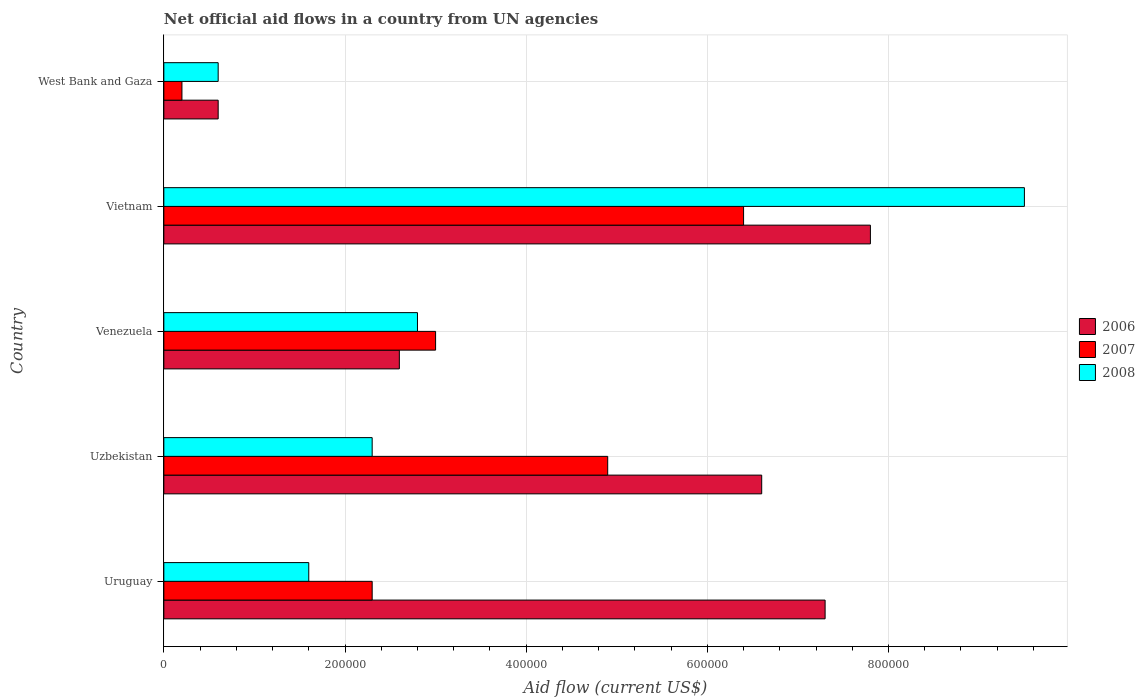Are the number of bars on each tick of the Y-axis equal?
Provide a short and direct response. Yes. How many bars are there on the 4th tick from the top?
Provide a succinct answer. 3. How many bars are there on the 2nd tick from the bottom?
Keep it short and to the point. 3. What is the label of the 4th group of bars from the top?
Make the answer very short. Uzbekistan. In how many cases, is the number of bars for a given country not equal to the number of legend labels?
Your response must be concise. 0. What is the net official aid flow in 2008 in West Bank and Gaza?
Make the answer very short. 6.00e+04. Across all countries, what is the maximum net official aid flow in 2008?
Keep it short and to the point. 9.50e+05. In which country was the net official aid flow in 2006 maximum?
Keep it short and to the point. Vietnam. In which country was the net official aid flow in 2006 minimum?
Offer a terse response. West Bank and Gaza. What is the total net official aid flow in 2006 in the graph?
Ensure brevity in your answer.  2.49e+06. What is the difference between the net official aid flow in 2008 in Vietnam and that in West Bank and Gaza?
Provide a short and direct response. 8.90e+05. What is the average net official aid flow in 2006 per country?
Your response must be concise. 4.98e+05. In how many countries, is the net official aid flow in 2006 greater than 560000 US$?
Provide a short and direct response. 3. Is the net official aid flow in 2006 in Uruguay less than that in Venezuela?
Offer a terse response. No. What is the difference between the highest and the lowest net official aid flow in 2006?
Ensure brevity in your answer.  7.20e+05. In how many countries, is the net official aid flow in 2007 greater than the average net official aid flow in 2007 taken over all countries?
Provide a short and direct response. 2. Is the sum of the net official aid flow in 2008 in Venezuela and Vietnam greater than the maximum net official aid flow in 2007 across all countries?
Ensure brevity in your answer.  Yes. Are all the bars in the graph horizontal?
Keep it short and to the point. Yes. What is the difference between two consecutive major ticks on the X-axis?
Offer a terse response. 2.00e+05. Does the graph contain any zero values?
Your answer should be very brief. No. Does the graph contain grids?
Your response must be concise. Yes. Where does the legend appear in the graph?
Keep it short and to the point. Center right. How many legend labels are there?
Keep it short and to the point. 3. How are the legend labels stacked?
Give a very brief answer. Vertical. What is the title of the graph?
Offer a terse response. Net official aid flows in a country from UN agencies. What is the label or title of the X-axis?
Offer a terse response. Aid flow (current US$). What is the Aid flow (current US$) in 2006 in Uruguay?
Your answer should be very brief. 7.30e+05. What is the Aid flow (current US$) of 2008 in Uruguay?
Provide a short and direct response. 1.60e+05. What is the Aid flow (current US$) of 2006 in Uzbekistan?
Give a very brief answer. 6.60e+05. What is the Aid flow (current US$) of 2007 in Venezuela?
Offer a very short reply. 3.00e+05. What is the Aid flow (current US$) in 2006 in Vietnam?
Ensure brevity in your answer.  7.80e+05. What is the Aid flow (current US$) in 2007 in Vietnam?
Your answer should be compact. 6.40e+05. What is the Aid flow (current US$) in 2008 in Vietnam?
Offer a very short reply. 9.50e+05. What is the Aid flow (current US$) in 2006 in West Bank and Gaza?
Keep it short and to the point. 6.00e+04. What is the Aid flow (current US$) of 2007 in West Bank and Gaza?
Your response must be concise. 2.00e+04. Across all countries, what is the maximum Aid flow (current US$) in 2006?
Give a very brief answer. 7.80e+05. Across all countries, what is the maximum Aid flow (current US$) of 2007?
Your answer should be very brief. 6.40e+05. Across all countries, what is the maximum Aid flow (current US$) in 2008?
Your answer should be compact. 9.50e+05. Across all countries, what is the minimum Aid flow (current US$) of 2008?
Ensure brevity in your answer.  6.00e+04. What is the total Aid flow (current US$) of 2006 in the graph?
Your answer should be very brief. 2.49e+06. What is the total Aid flow (current US$) in 2007 in the graph?
Give a very brief answer. 1.68e+06. What is the total Aid flow (current US$) in 2008 in the graph?
Offer a terse response. 1.68e+06. What is the difference between the Aid flow (current US$) in 2007 in Uruguay and that in Uzbekistan?
Offer a very short reply. -2.60e+05. What is the difference between the Aid flow (current US$) in 2006 in Uruguay and that in Venezuela?
Keep it short and to the point. 4.70e+05. What is the difference between the Aid flow (current US$) in 2008 in Uruguay and that in Venezuela?
Give a very brief answer. -1.20e+05. What is the difference between the Aid flow (current US$) in 2007 in Uruguay and that in Vietnam?
Ensure brevity in your answer.  -4.10e+05. What is the difference between the Aid flow (current US$) in 2008 in Uruguay and that in Vietnam?
Make the answer very short. -7.90e+05. What is the difference between the Aid flow (current US$) in 2006 in Uruguay and that in West Bank and Gaza?
Offer a terse response. 6.70e+05. What is the difference between the Aid flow (current US$) in 2008 in Uruguay and that in West Bank and Gaza?
Keep it short and to the point. 1.00e+05. What is the difference between the Aid flow (current US$) of 2008 in Uzbekistan and that in Venezuela?
Ensure brevity in your answer.  -5.00e+04. What is the difference between the Aid flow (current US$) in 2007 in Uzbekistan and that in Vietnam?
Your answer should be compact. -1.50e+05. What is the difference between the Aid flow (current US$) of 2008 in Uzbekistan and that in Vietnam?
Your answer should be very brief. -7.20e+05. What is the difference between the Aid flow (current US$) in 2007 in Uzbekistan and that in West Bank and Gaza?
Provide a short and direct response. 4.70e+05. What is the difference between the Aid flow (current US$) in 2008 in Uzbekistan and that in West Bank and Gaza?
Keep it short and to the point. 1.70e+05. What is the difference between the Aid flow (current US$) in 2006 in Venezuela and that in Vietnam?
Make the answer very short. -5.20e+05. What is the difference between the Aid flow (current US$) of 2008 in Venezuela and that in Vietnam?
Provide a short and direct response. -6.70e+05. What is the difference between the Aid flow (current US$) of 2008 in Venezuela and that in West Bank and Gaza?
Your answer should be compact. 2.20e+05. What is the difference between the Aid flow (current US$) of 2006 in Vietnam and that in West Bank and Gaza?
Make the answer very short. 7.20e+05. What is the difference between the Aid flow (current US$) of 2007 in Vietnam and that in West Bank and Gaza?
Give a very brief answer. 6.20e+05. What is the difference between the Aid flow (current US$) in 2008 in Vietnam and that in West Bank and Gaza?
Your answer should be very brief. 8.90e+05. What is the difference between the Aid flow (current US$) in 2006 in Uruguay and the Aid flow (current US$) in 2007 in Uzbekistan?
Your answer should be compact. 2.40e+05. What is the difference between the Aid flow (current US$) of 2006 in Uruguay and the Aid flow (current US$) of 2008 in Venezuela?
Offer a very short reply. 4.50e+05. What is the difference between the Aid flow (current US$) in 2006 in Uruguay and the Aid flow (current US$) in 2008 in Vietnam?
Offer a very short reply. -2.20e+05. What is the difference between the Aid flow (current US$) of 2007 in Uruguay and the Aid flow (current US$) of 2008 in Vietnam?
Make the answer very short. -7.20e+05. What is the difference between the Aid flow (current US$) of 2006 in Uruguay and the Aid flow (current US$) of 2007 in West Bank and Gaza?
Keep it short and to the point. 7.10e+05. What is the difference between the Aid flow (current US$) in 2006 in Uruguay and the Aid flow (current US$) in 2008 in West Bank and Gaza?
Your answer should be very brief. 6.70e+05. What is the difference between the Aid flow (current US$) in 2006 in Uzbekistan and the Aid flow (current US$) in 2007 in Venezuela?
Offer a very short reply. 3.60e+05. What is the difference between the Aid flow (current US$) in 2006 in Uzbekistan and the Aid flow (current US$) in 2008 in Venezuela?
Offer a very short reply. 3.80e+05. What is the difference between the Aid flow (current US$) in 2007 in Uzbekistan and the Aid flow (current US$) in 2008 in Venezuela?
Your answer should be very brief. 2.10e+05. What is the difference between the Aid flow (current US$) in 2006 in Uzbekistan and the Aid flow (current US$) in 2007 in Vietnam?
Your response must be concise. 2.00e+04. What is the difference between the Aid flow (current US$) of 2006 in Uzbekistan and the Aid flow (current US$) of 2008 in Vietnam?
Offer a very short reply. -2.90e+05. What is the difference between the Aid flow (current US$) of 2007 in Uzbekistan and the Aid flow (current US$) of 2008 in Vietnam?
Ensure brevity in your answer.  -4.60e+05. What is the difference between the Aid flow (current US$) of 2006 in Uzbekistan and the Aid flow (current US$) of 2007 in West Bank and Gaza?
Make the answer very short. 6.40e+05. What is the difference between the Aid flow (current US$) of 2006 in Uzbekistan and the Aid flow (current US$) of 2008 in West Bank and Gaza?
Ensure brevity in your answer.  6.00e+05. What is the difference between the Aid flow (current US$) of 2006 in Venezuela and the Aid flow (current US$) of 2007 in Vietnam?
Offer a terse response. -3.80e+05. What is the difference between the Aid flow (current US$) in 2006 in Venezuela and the Aid flow (current US$) in 2008 in Vietnam?
Offer a very short reply. -6.90e+05. What is the difference between the Aid flow (current US$) in 2007 in Venezuela and the Aid flow (current US$) in 2008 in Vietnam?
Your response must be concise. -6.50e+05. What is the difference between the Aid flow (current US$) in 2006 in Venezuela and the Aid flow (current US$) in 2007 in West Bank and Gaza?
Keep it short and to the point. 2.40e+05. What is the difference between the Aid flow (current US$) of 2006 in Venezuela and the Aid flow (current US$) of 2008 in West Bank and Gaza?
Make the answer very short. 2.00e+05. What is the difference between the Aid flow (current US$) in 2006 in Vietnam and the Aid flow (current US$) in 2007 in West Bank and Gaza?
Ensure brevity in your answer.  7.60e+05. What is the difference between the Aid flow (current US$) of 2006 in Vietnam and the Aid flow (current US$) of 2008 in West Bank and Gaza?
Your answer should be compact. 7.20e+05. What is the difference between the Aid flow (current US$) in 2007 in Vietnam and the Aid flow (current US$) in 2008 in West Bank and Gaza?
Your response must be concise. 5.80e+05. What is the average Aid flow (current US$) of 2006 per country?
Offer a terse response. 4.98e+05. What is the average Aid flow (current US$) of 2007 per country?
Provide a succinct answer. 3.36e+05. What is the average Aid flow (current US$) in 2008 per country?
Make the answer very short. 3.36e+05. What is the difference between the Aid flow (current US$) in 2006 and Aid flow (current US$) in 2008 in Uruguay?
Offer a very short reply. 5.70e+05. What is the difference between the Aid flow (current US$) of 2007 and Aid flow (current US$) of 2008 in Uruguay?
Make the answer very short. 7.00e+04. What is the difference between the Aid flow (current US$) of 2006 and Aid flow (current US$) of 2008 in Uzbekistan?
Provide a succinct answer. 4.30e+05. What is the difference between the Aid flow (current US$) in 2006 and Aid flow (current US$) in 2007 in Venezuela?
Ensure brevity in your answer.  -4.00e+04. What is the difference between the Aid flow (current US$) of 2006 and Aid flow (current US$) of 2008 in Venezuela?
Provide a short and direct response. -2.00e+04. What is the difference between the Aid flow (current US$) of 2007 and Aid flow (current US$) of 2008 in Venezuela?
Provide a short and direct response. 2.00e+04. What is the difference between the Aid flow (current US$) in 2006 and Aid flow (current US$) in 2007 in Vietnam?
Offer a terse response. 1.40e+05. What is the difference between the Aid flow (current US$) of 2007 and Aid flow (current US$) of 2008 in Vietnam?
Offer a very short reply. -3.10e+05. What is the difference between the Aid flow (current US$) of 2006 and Aid flow (current US$) of 2007 in West Bank and Gaza?
Make the answer very short. 4.00e+04. What is the difference between the Aid flow (current US$) of 2006 and Aid flow (current US$) of 2008 in West Bank and Gaza?
Give a very brief answer. 0. What is the ratio of the Aid flow (current US$) of 2006 in Uruguay to that in Uzbekistan?
Give a very brief answer. 1.11. What is the ratio of the Aid flow (current US$) of 2007 in Uruguay to that in Uzbekistan?
Offer a very short reply. 0.47. What is the ratio of the Aid flow (current US$) in 2008 in Uruguay to that in Uzbekistan?
Give a very brief answer. 0.7. What is the ratio of the Aid flow (current US$) of 2006 in Uruguay to that in Venezuela?
Provide a short and direct response. 2.81. What is the ratio of the Aid flow (current US$) in 2007 in Uruguay to that in Venezuela?
Your response must be concise. 0.77. What is the ratio of the Aid flow (current US$) in 2008 in Uruguay to that in Venezuela?
Provide a short and direct response. 0.57. What is the ratio of the Aid flow (current US$) in 2006 in Uruguay to that in Vietnam?
Offer a terse response. 0.94. What is the ratio of the Aid flow (current US$) of 2007 in Uruguay to that in Vietnam?
Provide a short and direct response. 0.36. What is the ratio of the Aid flow (current US$) in 2008 in Uruguay to that in Vietnam?
Offer a terse response. 0.17. What is the ratio of the Aid flow (current US$) in 2006 in Uruguay to that in West Bank and Gaza?
Provide a short and direct response. 12.17. What is the ratio of the Aid flow (current US$) in 2008 in Uruguay to that in West Bank and Gaza?
Make the answer very short. 2.67. What is the ratio of the Aid flow (current US$) of 2006 in Uzbekistan to that in Venezuela?
Make the answer very short. 2.54. What is the ratio of the Aid flow (current US$) of 2007 in Uzbekistan to that in Venezuela?
Ensure brevity in your answer.  1.63. What is the ratio of the Aid flow (current US$) in 2008 in Uzbekistan to that in Venezuela?
Offer a terse response. 0.82. What is the ratio of the Aid flow (current US$) in 2006 in Uzbekistan to that in Vietnam?
Give a very brief answer. 0.85. What is the ratio of the Aid flow (current US$) in 2007 in Uzbekistan to that in Vietnam?
Ensure brevity in your answer.  0.77. What is the ratio of the Aid flow (current US$) of 2008 in Uzbekistan to that in Vietnam?
Your answer should be very brief. 0.24. What is the ratio of the Aid flow (current US$) in 2007 in Uzbekistan to that in West Bank and Gaza?
Give a very brief answer. 24.5. What is the ratio of the Aid flow (current US$) in 2008 in Uzbekistan to that in West Bank and Gaza?
Ensure brevity in your answer.  3.83. What is the ratio of the Aid flow (current US$) of 2007 in Venezuela to that in Vietnam?
Offer a very short reply. 0.47. What is the ratio of the Aid flow (current US$) of 2008 in Venezuela to that in Vietnam?
Your response must be concise. 0.29. What is the ratio of the Aid flow (current US$) of 2006 in Venezuela to that in West Bank and Gaza?
Provide a succinct answer. 4.33. What is the ratio of the Aid flow (current US$) of 2007 in Venezuela to that in West Bank and Gaza?
Give a very brief answer. 15. What is the ratio of the Aid flow (current US$) in 2008 in Venezuela to that in West Bank and Gaza?
Your response must be concise. 4.67. What is the ratio of the Aid flow (current US$) in 2006 in Vietnam to that in West Bank and Gaza?
Offer a terse response. 13. What is the ratio of the Aid flow (current US$) in 2007 in Vietnam to that in West Bank and Gaza?
Provide a short and direct response. 32. What is the ratio of the Aid flow (current US$) in 2008 in Vietnam to that in West Bank and Gaza?
Your answer should be very brief. 15.83. What is the difference between the highest and the second highest Aid flow (current US$) in 2007?
Give a very brief answer. 1.50e+05. What is the difference between the highest and the second highest Aid flow (current US$) in 2008?
Provide a short and direct response. 6.70e+05. What is the difference between the highest and the lowest Aid flow (current US$) in 2006?
Provide a succinct answer. 7.20e+05. What is the difference between the highest and the lowest Aid flow (current US$) of 2007?
Give a very brief answer. 6.20e+05. What is the difference between the highest and the lowest Aid flow (current US$) of 2008?
Provide a succinct answer. 8.90e+05. 